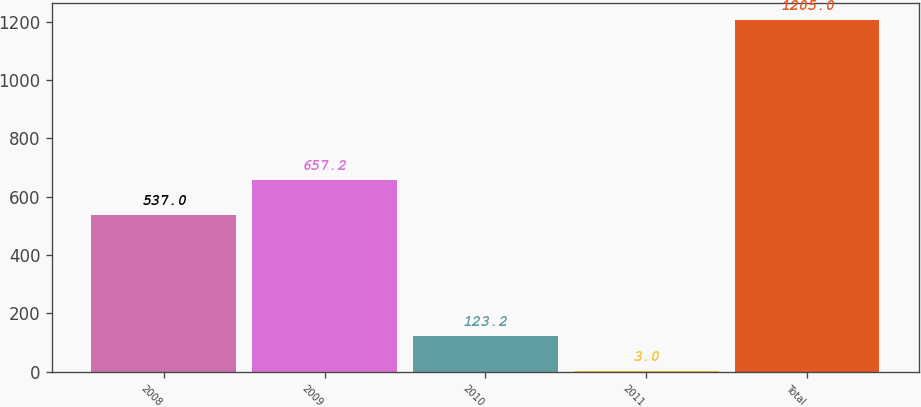Convert chart. <chart><loc_0><loc_0><loc_500><loc_500><bar_chart><fcel>2008<fcel>2009<fcel>2010<fcel>2011<fcel>Total<nl><fcel>537<fcel>657.2<fcel>123.2<fcel>3<fcel>1205<nl></chart> 